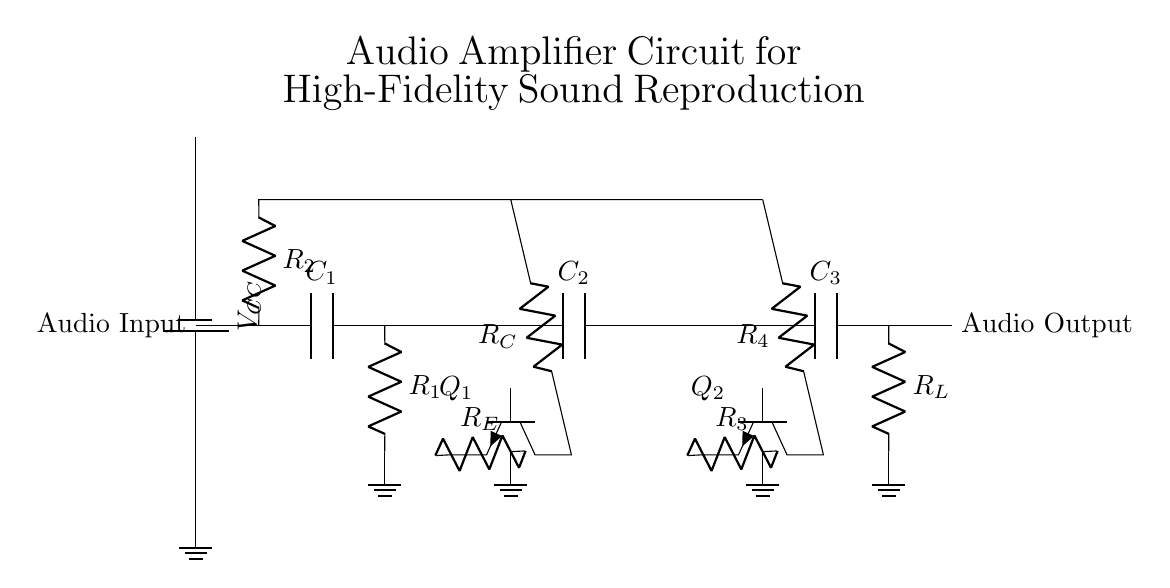What is the purpose of the capacitor C1? C1 is a coupling capacitor, which blocks DC voltage while allowing AC signals to pass through, thus protecting downstream components from DC bias.
Answer: Coupling What type of transistors are used in this circuit? The circuit shows two npn transistors, Q1 and Q2, which are used for amplification due to their transistor configuration allowing for better control of current flow.
Answer: Npn How many resistors are in this circuit? There are four resistors labeled R1, R2, R3, and R4, which help set the gain and stability of the amplifier circuit.
Answer: Four What is the role of C3? C3 is an output coupling capacitor which blocks DC while allowing the amplified AC audio signal to pass to the load resistor, thus ensuring that no DC offset affects the output devices.
Answer: Output coupling What happens if R_E is increased? Increasing R_E enhances the emitter stability of Q1, resulting in improved linearity and reduced distortion of the audio signal through negative feedback, affecting the overall fidelity.
Answer: Stability increases What is the significance of the power supply voltage value? The voltage value \(V_{CC}\) powers the entire circuit, determining the maximum output voltage swing capability of the amplifier. A higher \(V_{CC}\) can allow for a higher output signal level without distortion.
Answer: Powering the circuit 